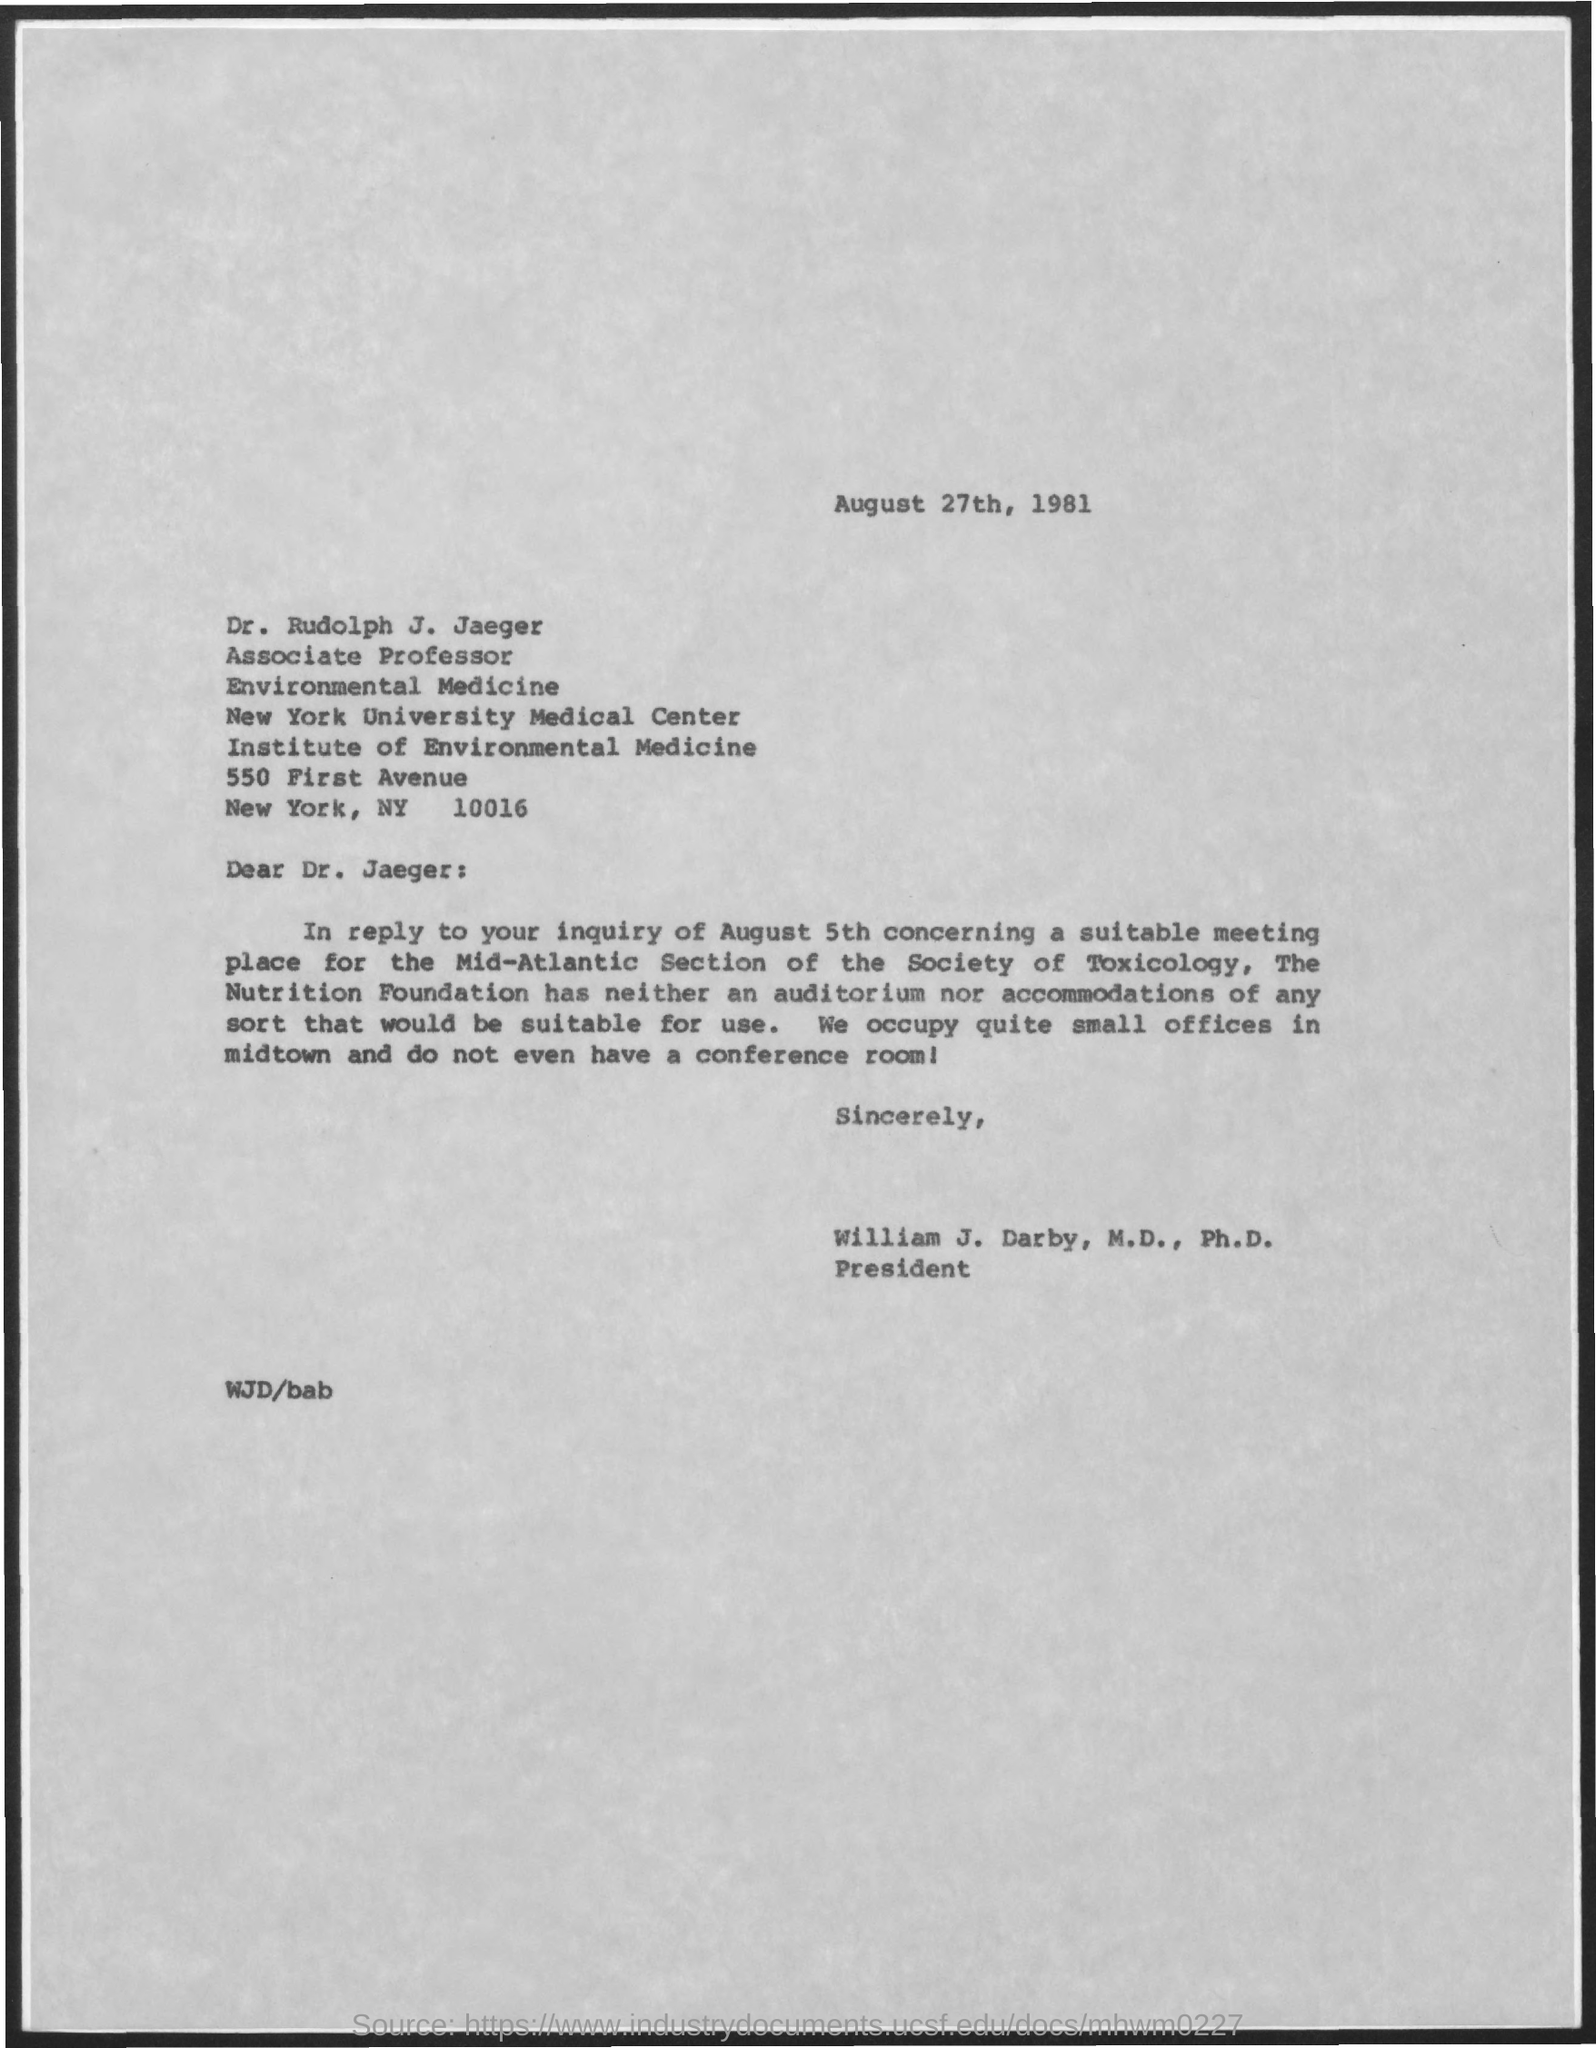Mention a couple of crucial points in this snapshot. The date on the document is August 27th, 1981. 